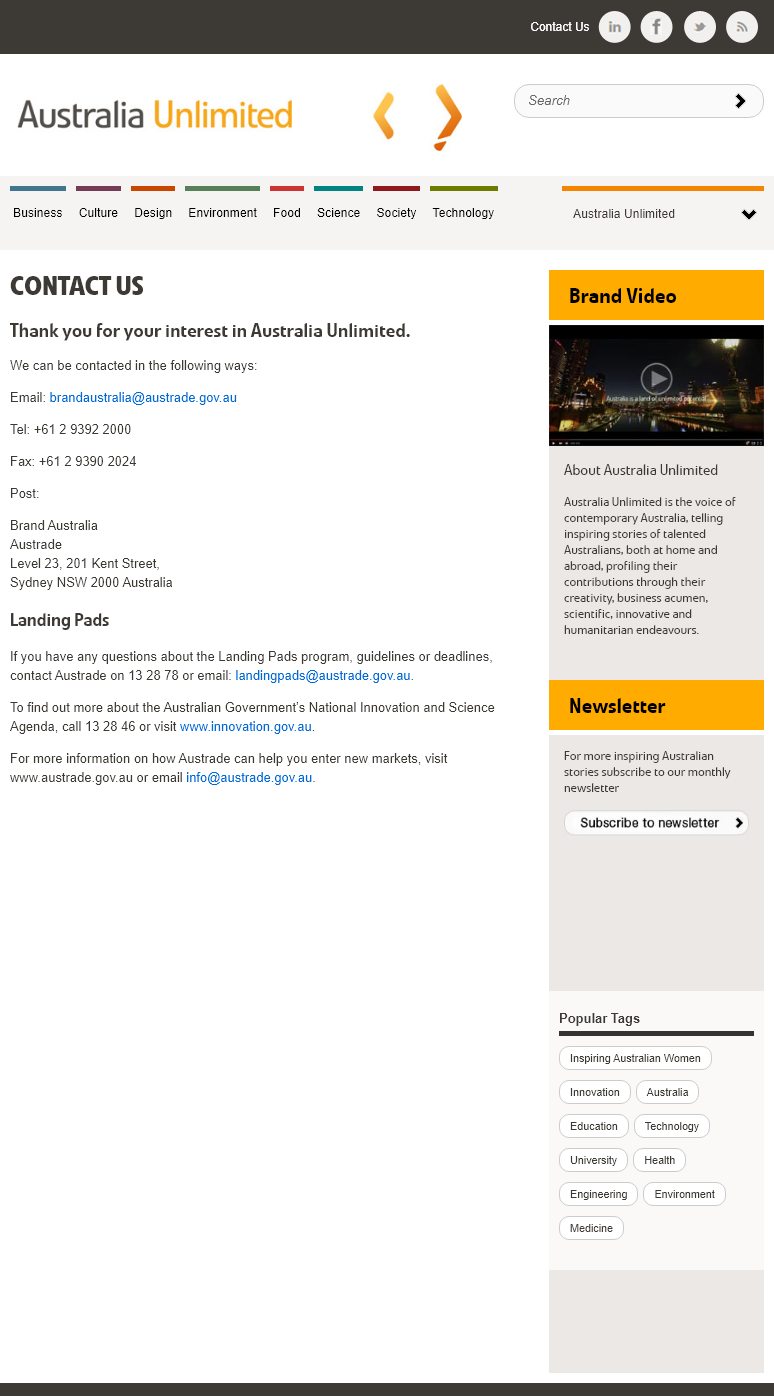Highlight a few significant elements in this photo. You can obtain information about the Australian Government's National Innovation and Science Agenda by contacting them via telephone or accessing their website. Austrade must be contacted via phone or email if questions regarding the Landing Pads program arise. Contacting Austrade through their website or email can aid in exploring opportunities to enter new markets. 